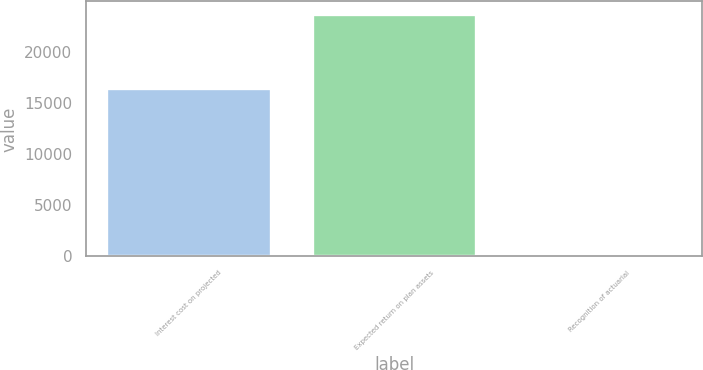Convert chart. <chart><loc_0><loc_0><loc_500><loc_500><bar_chart><fcel>Interest cost on projected<fcel>Expected return on plan assets<fcel>Recognition of actuarial<nl><fcel>16453<fcel>23722<fcel>371<nl></chart> 